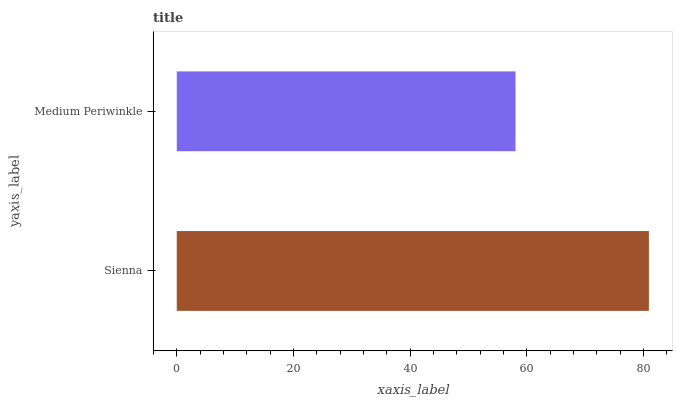Is Medium Periwinkle the minimum?
Answer yes or no. Yes. Is Sienna the maximum?
Answer yes or no. Yes. Is Medium Periwinkle the maximum?
Answer yes or no. No. Is Sienna greater than Medium Periwinkle?
Answer yes or no. Yes. Is Medium Periwinkle less than Sienna?
Answer yes or no. Yes. Is Medium Periwinkle greater than Sienna?
Answer yes or no. No. Is Sienna less than Medium Periwinkle?
Answer yes or no. No. Is Sienna the high median?
Answer yes or no. Yes. Is Medium Periwinkle the low median?
Answer yes or no. Yes. Is Medium Periwinkle the high median?
Answer yes or no. No. Is Sienna the low median?
Answer yes or no. No. 